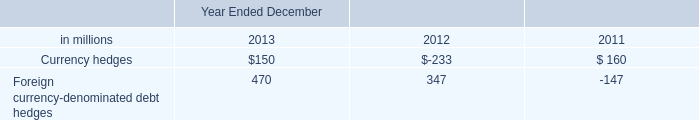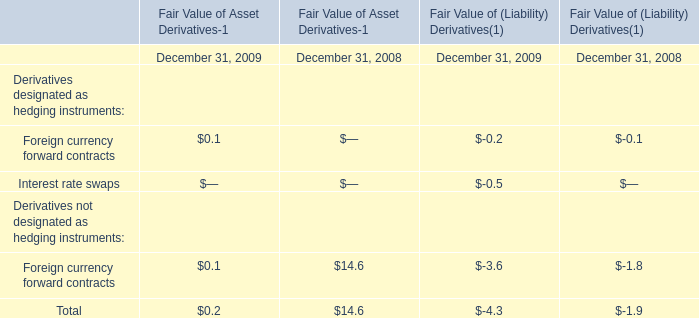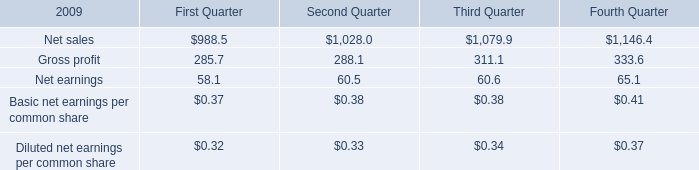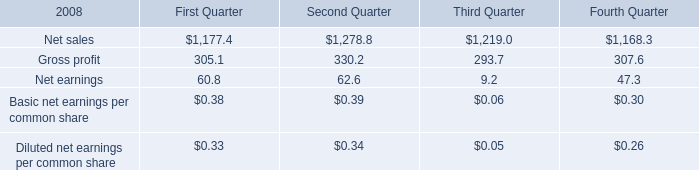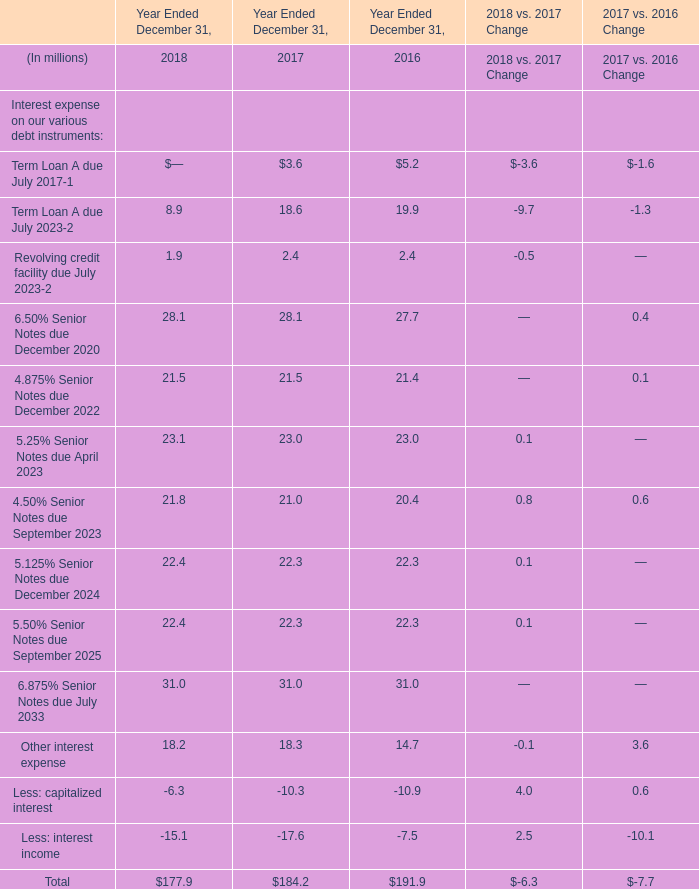Which year Ended December 31 does Other interest expense reach the largest value? 
Answer: 2017. 